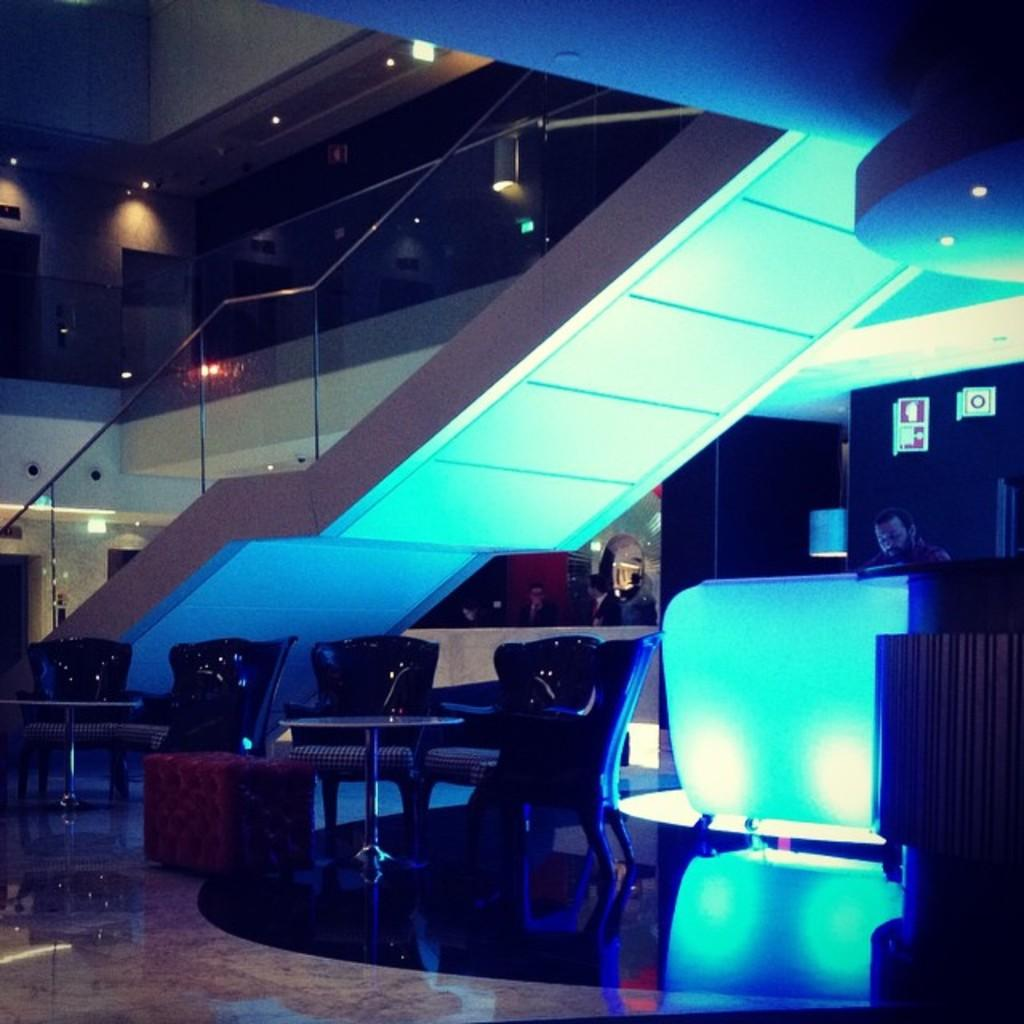What is hanging from the ceiling in the image? Lights are attached to the ceiling in the image. Who or what can be seen in the image? There are people in the image. What type of furniture is present in the image? Chairs and tables are visible in the image. Are there any indications or directions provided in the image? Yes, there are sign boards in the image. How many fingers does the page in the image have? There is no page present in the image, and therefore no fingers can be counted. Does the existence of the sign boards in the image prove the existence of a parallel universe? The presence of sign boards in the image does not provide any information about the existence of a parallel universe. 